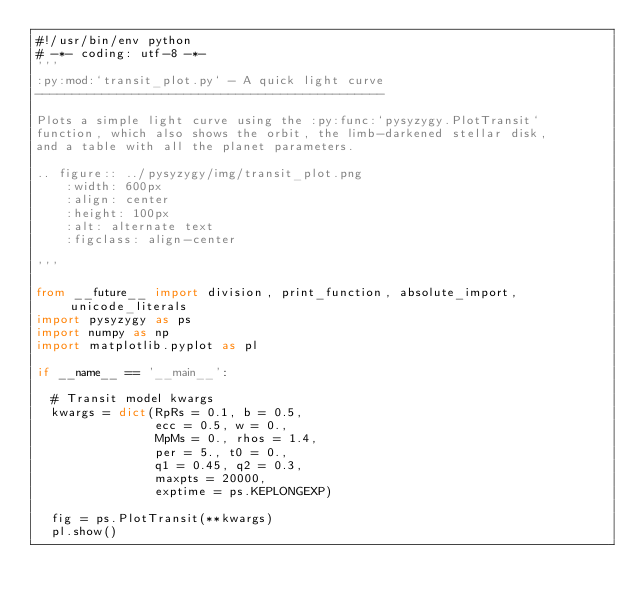<code> <loc_0><loc_0><loc_500><loc_500><_Python_>#!/usr/bin/env python
# -*- coding: utf-8 -*-
'''
:py:mod:`transit_plot.py` - A quick light curve
-----------------------------------------------

Plots a simple light curve using the :py:func:`pysyzygy.PlotTransit`
function, which also shows the orbit, the limb-darkened stellar disk,
and a table with all the planet parameters.

.. figure:: ../pysyzygy/img/transit_plot.png
    :width: 600px
    :align: center
    :height: 100px
    :alt: alternate text
    :figclass: align-center

'''

from __future__ import division, print_function, absolute_import, unicode_literals
import pysyzygy as ps
import numpy as np
import matplotlib.pyplot as pl

if __name__ == '__main__':

  # Transit model kwargs
  kwargs = dict(RpRs = 0.1, b = 0.5, 
                ecc = 0.5, w = 0.,
                MpMs = 0., rhos = 1.4,
                per = 5., t0 = 0.,
                q1 = 0.45, q2 = 0.3,
                maxpts = 20000,
                exptime = ps.KEPLONGEXP)

  fig = ps.PlotTransit(**kwargs)
  pl.show()</code> 